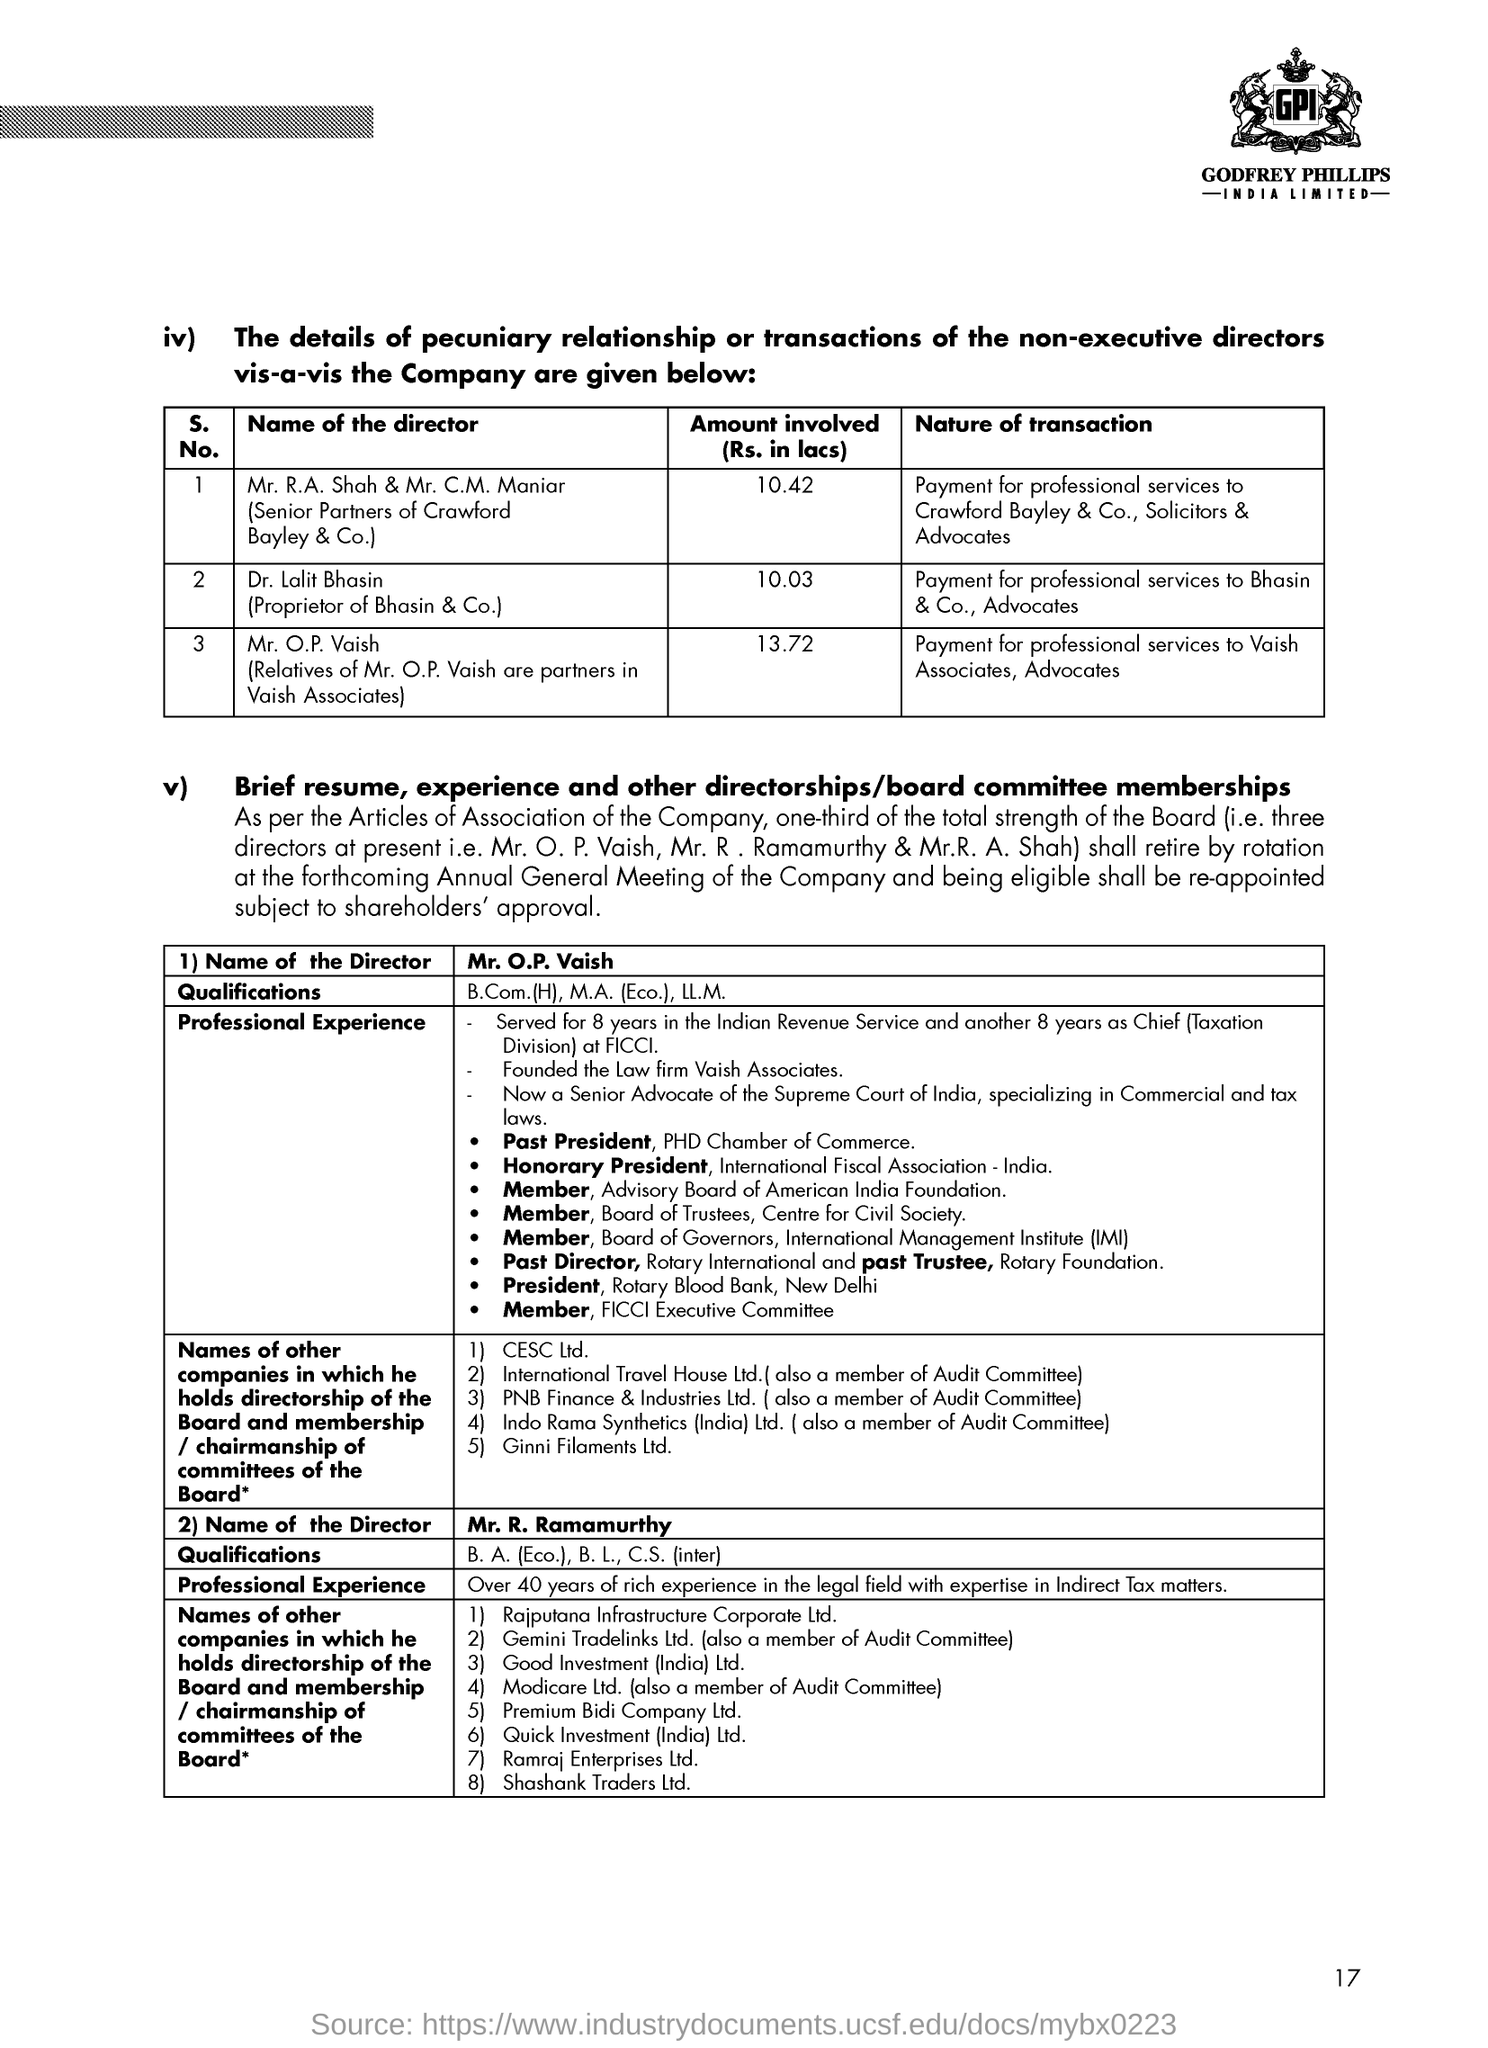What is the nature of transaction by Dr. Lalit Bhasin?
Keep it short and to the point. Payment for professional services to Bhasin & Co., Advocates. 